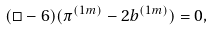<formula> <loc_0><loc_0><loc_500><loc_500>( \Box - 6 ) ( \pi ^ { ( 1 m ) } - 2 b ^ { ( 1 m ) } ) = 0 ,</formula> 